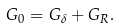<formula> <loc_0><loc_0><loc_500><loc_500>G _ { 0 } = G _ { \delta } + G _ { R } .</formula> 